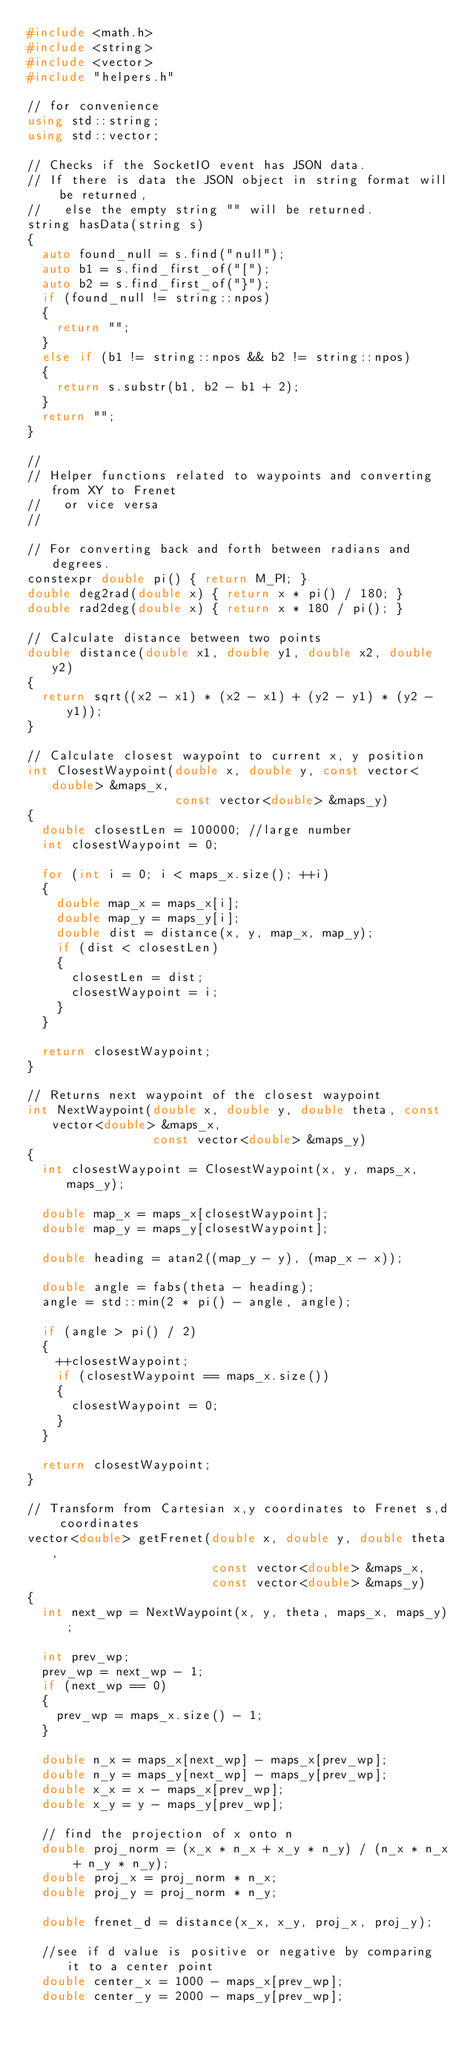Convert code to text. <code><loc_0><loc_0><loc_500><loc_500><_C++_>#include <math.h>
#include <string>
#include <vector>
#include "helpers.h"

// for convenience
using std::string;
using std::vector;

// Checks if the SocketIO event has JSON data.
// If there is data the JSON object in string format will be returned,
//   else the empty string "" will be returned.
string hasData(string s)
{
  auto found_null = s.find("null");
  auto b1 = s.find_first_of("[");
  auto b2 = s.find_first_of("}");
  if (found_null != string::npos)
  {
    return "";
  }
  else if (b1 != string::npos && b2 != string::npos)
  {
    return s.substr(b1, b2 - b1 + 2);
  }
  return "";
}

//
// Helper functions related to waypoints and converting from XY to Frenet
//   or vice versa
//

// For converting back and forth between radians and degrees.
constexpr double pi() { return M_PI; }
double deg2rad(double x) { return x * pi() / 180; }
double rad2deg(double x) { return x * 180 / pi(); }

// Calculate distance between two points
double distance(double x1, double y1, double x2, double y2)
{
  return sqrt((x2 - x1) * (x2 - x1) + (y2 - y1) * (y2 - y1));
}

// Calculate closest waypoint to current x, y position
int ClosestWaypoint(double x, double y, const vector<double> &maps_x,
                    const vector<double> &maps_y)
{
  double closestLen = 100000; //large number
  int closestWaypoint = 0;

  for (int i = 0; i < maps_x.size(); ++i)
  {
    double map_x = maps_x[i];
    double map_y = maps_y[i];
    double dist = distance(x, y, map_x, map_y);
    if (dist < closestLen)
    {
      closestLen = dist;
      closestWaypoint = i;
    }
  }

  return closestWaypoint;
}

// Returns next waypoint of the closest waypoint
int NextWaypoint(double x, double y, double theta, const vector<double> &maps_x,
                 const vector<double> &maps_y)
{
  int closestWaypoint = ClosestWaypoint(x, y, maps_x, maps_y);

  double map_x = maps_x[closestWaypoint];
  double map_y = maps_y[closestWaypoint];

  double heading = atan2((map_y - y), (map_x - x));

  double angle = fabs(theta - heading);
  angle = std::min(2 * pi() - angle, angle);

  if (angle > pi() / 2)
  {
    ++closestWaypoint;
    if (closestWaypoint == maps_x.size())
    {
      closestWaypoint = 0;
    }
  }

  return closestWaypoint;
}

// Transform from Cartesian x,y coordinates to Frenet s,d coordinates
vector<double> getFrenet(double x, double y, double theta,
                         const vector<double> &maps_x,
                         const vector<double> &maps_y)
{
  int next_wp = NextWaypoint(x, y, theta, maps_x, maps_y);

  int prev_wp;
  prev_wp = next_wp - 1;
  if (next_wp == 0)
  {
    prev_wp = maps_x.size() - 1;
  }

  double n_x = maps_x[next_wp] - maps_x[prev_wp];
  double n_y = maps_y[next_wp] - maps_y[prev_wp];
  double x_x = x - maps_x[prev_wp];
  double x_y = y - maps_y[prev_wp];

  // find the projection of x onto n
  double proj_norm = (x_x * n_x + x_y * n_y) / (n_x * n_x + n_y * n_y);
  double proj_x = proj_norm * n_x;
  double proj_y = proj_norm * n_y;

  double frenet_d = distance(x_x, x_y, proj_x, proj_y);

  //see if d value is positive or negative by comparing it to a center point
  double center_x = 1000 - maps_x[prev_wp];
  double center_y = 2000 - maps_y[prev_wp];</code> 